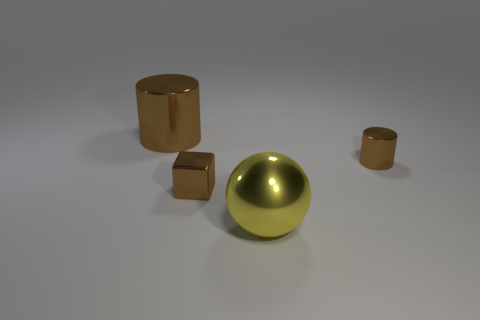The large object that is the same material as the ball is what color?
Provide a succinct answer. Brown. Is the number of big spheres right of the large yellow sphere less than the number of big red shiny objects?
Offer a terse response. No. What is the size of the brown metallic thing on the right side of the small brown shiny object that is on the left side of the brown thing to the right of the shiny ball?
Provide a short and direct response. Small. Do the tiny brown object that is to the right of the large yellow thing and the tiny cube have the same material?
Make the answer very short. Yes. There is another cylinder that is the same color as the big shiny cylinder; what is it made of?
Offer a very short reply. Metal. Is there any other thing that is the same shape as the big brown thing?
Make the answer very short. Yes. What number of things are big purple spheres or brown metal things?
Offer a very short reply. 3. What is the size of the other brown thing that is the same shape as the large brown object?
Your answer should be very brief. Small. Is there anything else that has the same size as the yellow ball?
Your answer should be very brief. Yes. How many other objects are there of the same color as the metallic cube?
Offer a terse response. 2. 